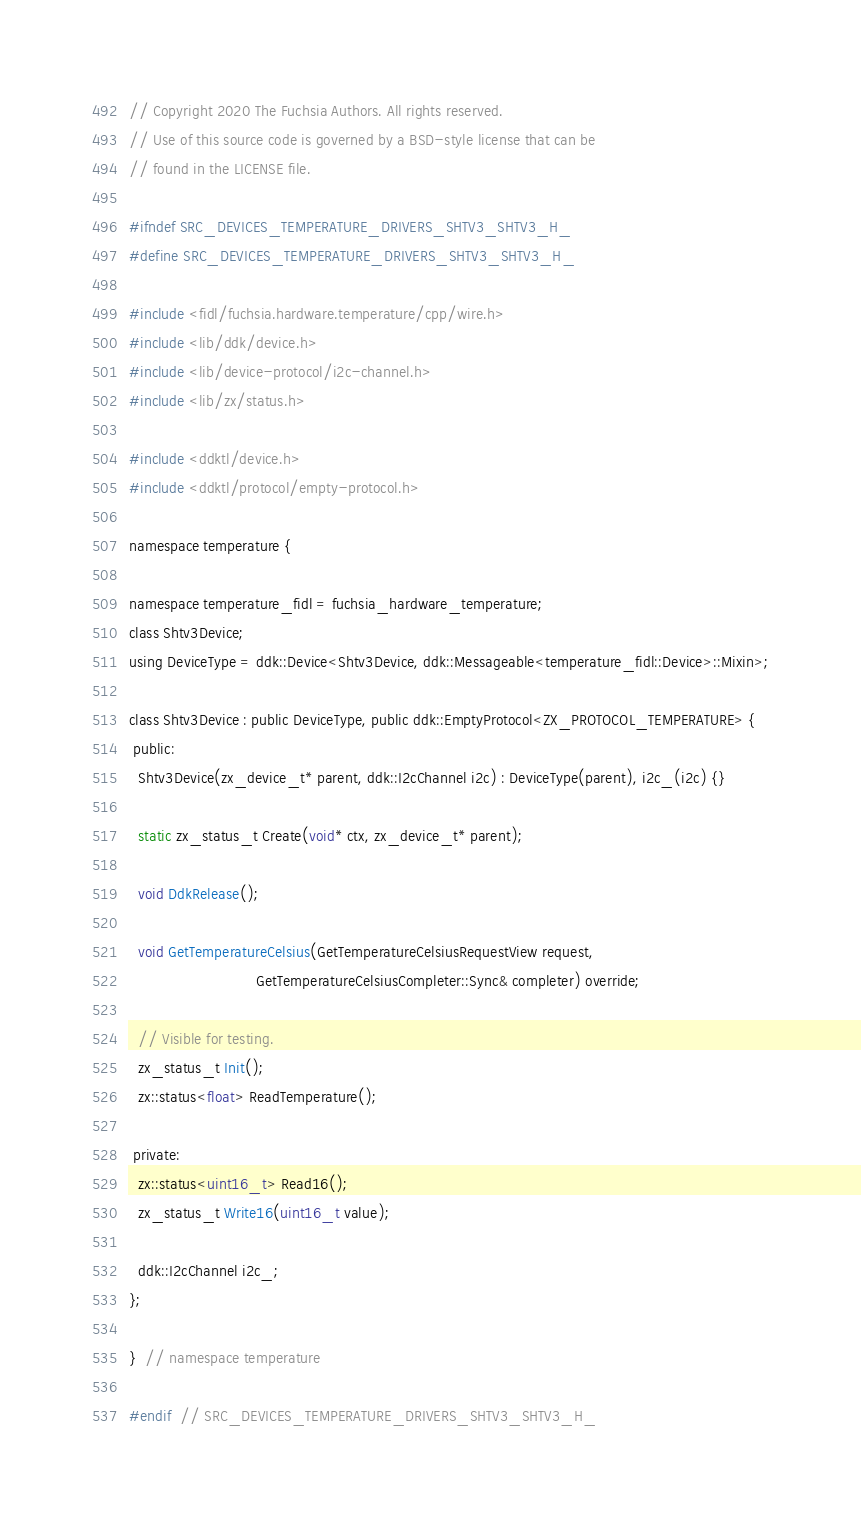<code> <loc_0><loc_0><loc_500><loc_500><_C_>// Copyright 2020 The Fuchsia Authors. All rights reserved.
// Use of this source code is governed by a BSD-style license that can be
// found in the LICENSE file.

#ifndef SRC_DEVICES_TEMPERATURE_DRIVERS_SHTV3_SHTV3_H_
#define SRC_DEVICES_TEMPERATURE_DRIVERS_SHTV3_SHTV3_H_

#include <fidl/fuchsia.hardware.temperature/cpp/wire.h>
#include <lib/ddk/device.h>
#include <lib/device-protocol/i2c-channel.h>
#include <lib/zx/status.h>

#include <ddktl/device.h>
#include <ddktl/protocol/empty-protocol.h>

namespace temperature {

namespace temperature_fidl = fuchsia_hardware_temperature;
class Shtv3Device;
using DeviceType = ddk::Device<Shtv3Device, ddk::Messageable<temperature_fidl::Device>::Mixin>;

class Shtv3Device : public DeviceType, public ddk::EmptyProtocol<ZX_PROTOCOL_TEMPERATURE> {
 public:
  Shtv3Device(zx_device_t* parent, ddk::I2cChannel i2c) : DeviceType(parent), i2c_(i2c) {}

  static zx_status_t Create(void* ctx, zx_device_t* parent);

  void DdkRelease();

  void GetTemperatureCelsius(GetTemperatureCelsiusRequestView request,
                             GetTemperatureCelsiusCompleter::Sync& completer) override;

  // Visible for testing.
  zx_status_t Init();
  zx::status<float> ReadTemperature();

 private:
  zx::status<uint16_t> Read16();
  zx_status_t Write16(uint16_t value);

  ddk::I2cChannel i2c_;
};

}  // namespace temperature

#endif  // SRC_DEVICES_TEMPERATURE_DRIVERS_SHTV3_SHTV3_H_
</code> 